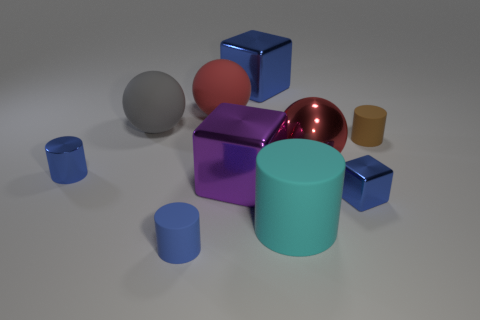There is a metallic block to the right of the cyan cylinder; what color is it?
Your answer should be very brief. Blue. Are the cyan object and the large cube in front of the tiny brown rubber cylinder made of the same material?
Provide a succinct answer. No. What material is the big gray sphere?
Provide a succinct answer. Rubber. There is a big blue object that is the same material as the large purple block; what shape is it?
Provide a succinct answer. Cube. What number of other things are the same shape as the big cyan thing?
Ensure brevity in your answer.  3. What number of big spheres are in front of the gray rubber thing?
Give a very brief answer. 1. There is a blue cylinder that is behind the purple metallic cube; does it have the same size as the metal cube to the right of the big metallic sphere?
Your response must be concise. Yes. What number of other things are the same size as the cyan matte thing?
Your answer should be compact. 5. There is a large ball to the left of the small object that is in front of the small blue metal object right of the gray thing; what is it made of?
Offer a terse response. Rubber. Is the size of the brown matte object the same as the red object that is to the left of the red metal object?
Your answer should be very brief. No. 